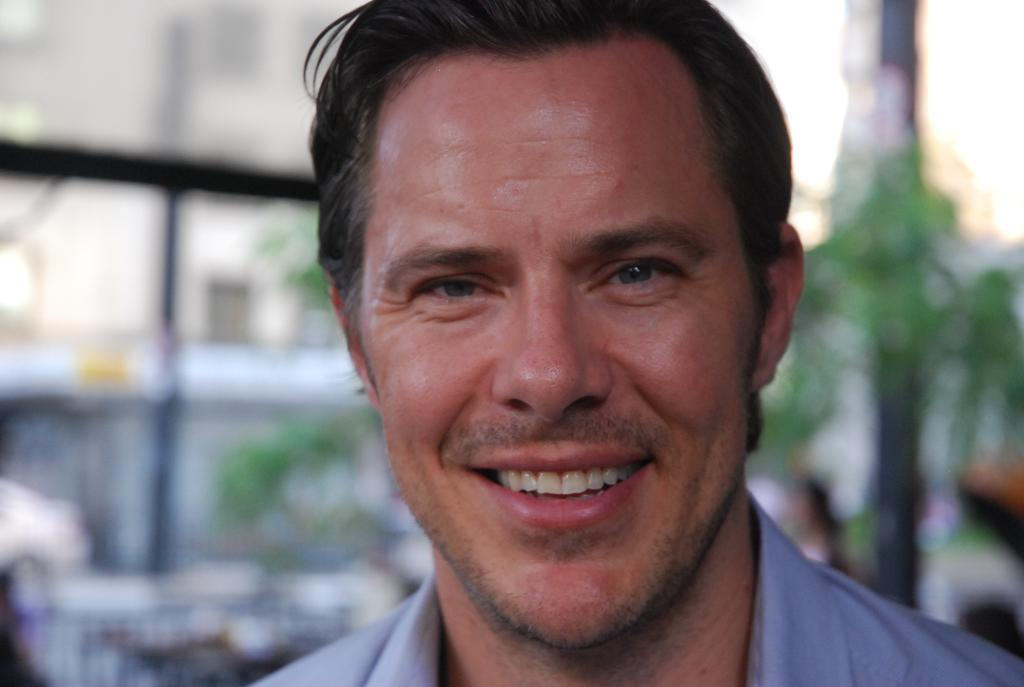Who is present in the image? There is a man in the image. What can be seen in the background of the image? There is sky, trees, and an iron grill visible in the background of the image. How many cars are parked in the sky in the image? There are no cars present in the sky in the image. 